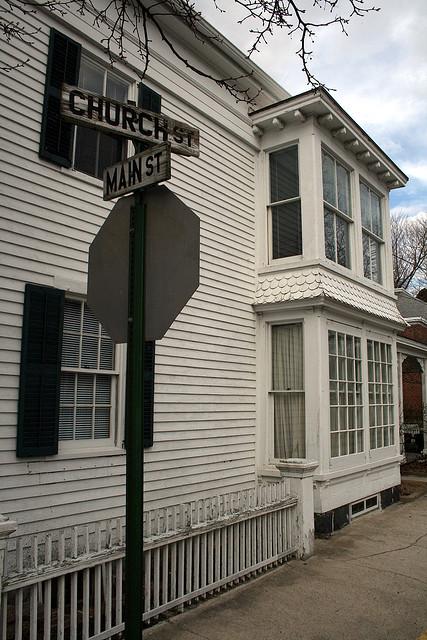What is this building?
Concise answer only. House. How many stories in the house?
Quick response, please. 2. This house is on the corner of what two streets?
Keep it brief. Church and main. What style of fence is shown?
Answer briefly. Picket. 